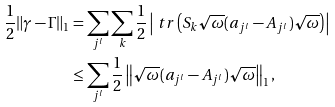<formula> <loc_0><loc_0><loc_500><loc_500>\frac { 1 } { 2 } \| \gamma - \Gamma \| _ { 1 } & = \sum _ { j ^ { l } } \sum _ { k } \frac { 1 } { 2 } \left | \ t r \left ( S _ { k } \sqrt { \omega } ( a _ { j ^ { l } } - A _ { j ^ { l } } ) \sqrt { \omega } \right ) \right | \\ & \leq \sum _ { j ^ { l } } \frac { 1 } { 2 } \left \| \sqrt { \omega } ( a _ { j ^ { l } } - A _ { j ^ { l } } ) \sqrt { \omega } \right \| _ { 1 } ,</formula> 